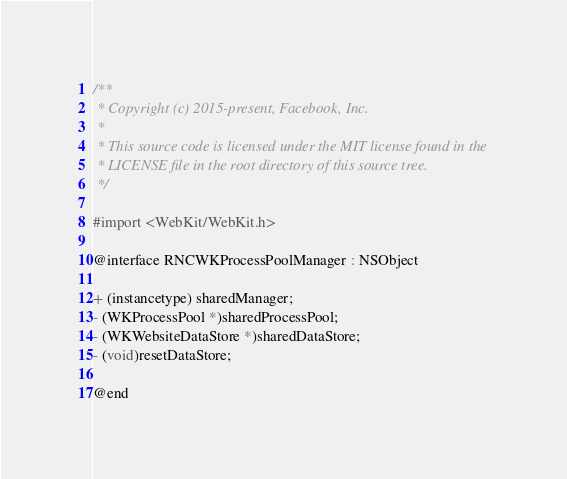<code> <loc_0><loc_0><loc_500><loc_500><_C_>/**
 * Copyright (c) 2015-present, Facebook, Inc.
 *
 * This source code is licensed under the MIT license found in the
 * LICENSE file in the root directory of this source tree.
 */

#import <WebKit/WebKit.h>

@interface RNCWKProcessPoolManager : NSObject

+ (instancetype) sharedManager;
- (WKProcessPool *)sharedProcessPool;
- (WKWebsiteDataStore *)sharedDataStore;
- (void)resetDataStore;

@end
</code> 